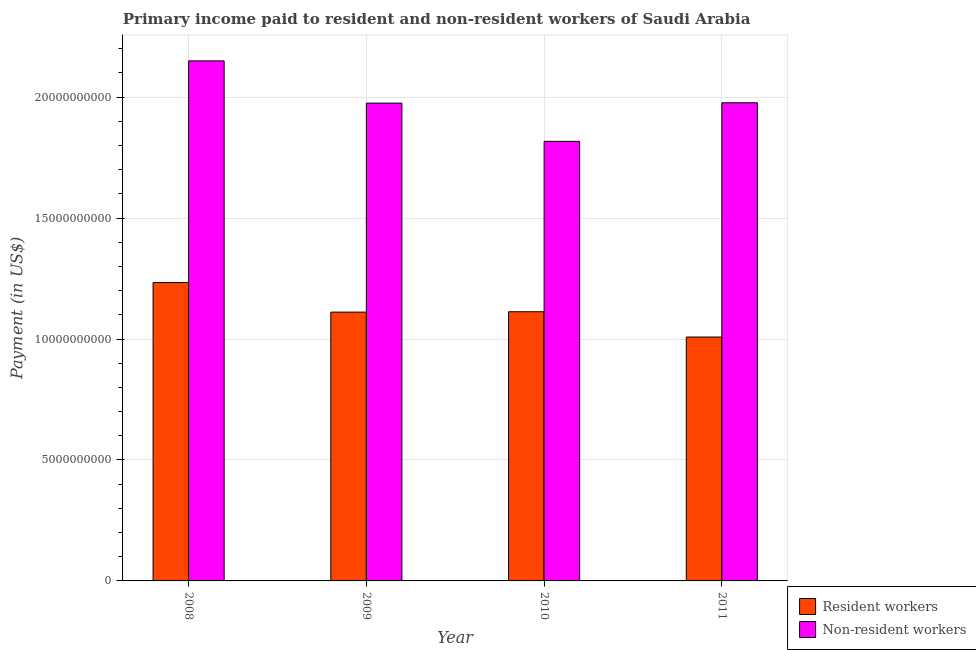How many groups of bars are there?
Your answer should be compact. 4. How many bars are there on the 4th tick from the left?
Your response must be concise. 2. What is the label of the 3rd group of bars from the left?
Offer a very short reply. 2010. In how many cases, is the number of bars for a given year not equal to the number of legend labels?
Give a very brief answer. 0. What is the payment made to non-resident workers in 2010?
Your answer should be very brief. 1.82e+1. Across all years, what is the maximum payment made to resident workers?
Your answer should be very brief. 1.23e+1. Across all years, what is the minimum payment made to resident workers?
Offer a terse response. 1.01e+1. In which year was the payment made to resident workers minimum?
Offer a very short reply. 2011. What is the total payment made to non-resident workers in the graph?
Ensure brevity in your answer.  7.92e+1. What is the difference between the payment made to resident workers in 2008 and that in 2011?
Provide a short and direct response. 2.25e+09. What is the difference between the payment made to resident workers in 2010 and the payment made to non-resident workers in 2009?
Give a very brief answer. 1.51e+07. What is the average payment made to non-resident workers per year?
Provide a short and direct response. 1.98e+1. In the year 2008, what is the difference between the payment made to resident workers and payment made to non-resident workers?
Provide a short and direct response. 0. In how many years, is the payment made to non-resident workers greater than 18000000000 US$?
Offer a very short reply. 4. What is the ratio of the payment made to resident workers in 2009 to that in 2011?
Your answer should be compact. 1.1. What is the difference between the highest and the second highest payment made to non-resident workers?
Ensure brevity in your answer.  1.73e+09. What is the difference between the highest and the lowest payment made to non-resident workers?
Your answer should be very brief. 3.33e+09. In how many years, is the payment made to resident workers greater than the average payment made to resident workers taken over all years?
Provide a succinct answer. 1. Is the sum of the payment made to non-resident workers in 2009 and 2010 greater than the maximum payment made to resident workers across all years?
Provide a succinct answer. Yes. What does the 2nd bar from the left in 2008 represents?
Ensure brevity in your answer.  Non-resident workers. What does the 1st bar from the right in 2008 represents?
Your answer should be compact. Non-resident workers. How many bars are there?
Your answer should be very brief. 8. How many years are there in the graph?
Your answer should be very brief. 4. What is the difference between two consecutive major ticks on the Y-axis?
Offer a very short reply. 5.00e+09. Does the graph contain any zero values?
Your answer should be very brief. No. Does the graph contain grids?
Keep it short and to the point. Yes. Where does the legend appear in the graph?
Provide a succinct answer. Bottom right. How many legend labels are there?
Your response must be concise. 2. How are the legend labels stacked?
Your answer should be compact. Vertical. What is the title of the graph?
Make the answer very short. Primary income paid to resident and non-resident workers of Saudi Arabia. Does "Imports" appear as one of the legend labels in the graph?
Your answer should be very brief. No. What is the label or title of the X-axis?
Offer a terse response. Year. What is the label or title of the Y-axis?
Provide a succinct answer. Payment (in US$). What is the Payment (in US$) in Resident workers in 2008?
Provide a short and direct response. 1.23e+1. What is the Payment (in US$) of Non-resident workers in 2008?
Your answer should be very brief. 2.15e+1. What is the Payment (in US$) in Resident workers in 2009?
Your answer should be compact. 1.11e+1. What is the Payment (in US$) in Non-resident workers in 2009?
Offer a terse response. 1.98e+1. What is the Payment (in US$) of Resident workers in 2010?
Provide a short and direct response. 1.11e+1. What is the Payment (in US$) of Non-resident workers in 2010?
Provide a succinct answer. 1.82e+1. What is the Payment (in US$) in Resident workers in 2011?
Ensure brevity in your answer.  1.01e+1. What is the Payment (in US$) of Non-resident workers in 2011?
Ensure brevity in your answer.  1.98e+1. Across all years, what is the maximum Payment (in US$) of Resident workers?
Your response must be concise. 1.23e+1. Across all years, what is the maximum Payment (in US$) of Non-resident workers?
Provide a succinct answer. 2.15e+1. Across all years, what is the minimum Payment (in US$) of Resident workers?
Offer a terse response. 1.01e+1. Across all years, what is the minimum Payment (in US$) in Non-resident workers?
Ensure brevity in your answer.  1.82e+1. What is the total Payment (in US$) in Resident workers in the graph?
Offer a terse response. 4.47e+1. What is the total Payment (in US$) of Non-resident workers in the graph?
Provide a succinct answer. 7.92e+1. What is the difference between the Payment (in US$) of Resident workers in 2008 and that in 2009?
Offer a terse response. 1.22e+09. What is the difference between the Payment (in US$) of Non-resident workers in 2008 and that in 2009?
Your answer should be compact. 1.75e+09. What is the difference between the Payment (in US$) of Resident workers in 2008 and that in 2010?
Make the answer very short. 1.21e+09. What is the difference between the Payment (in US$) of Non-resident workers in 2008 and that in 2010?
Your response must be concise. 3.33e+09. What is the difference between the Payment (in US$) of Resident workers in 2008 and that in 2011?
Offer a terse response. 2.25e+09. What is the difference between the Payment (in US$) of Non-resident workers in 2008 and that in 2011?
Your response must be concise. 1.73e+09. What is the difference between the Payment (in US$) in Resident workers in 2009 and that in 2010?
Offer a terse response. -1.51e+07. What is the difference between the Payment (in US$) of Non-resident workers in 2009 and that in 2010?
Offer a terse response. 1.58e+09. What is the difference between the Payment (in US$) in Resident workers in 2009 and that in 2011?
Your answer should be compact. 1.03e+09. What is the difference between the Payment (in US$) of Non-resident workers in 2009 and that in 2011?
Provide a short and direct response. -1.37e+07. What is the difference between the Payment (in US$) in Resident workers in 2010 and that in 2011?
Offer a very short reply. 1.05e+09. What is the difference between the Payment (in US$) of Non-resident workers in 2010 and that in 2011?
Your answer should be very brief. -1.59e+09. What is the difference between the Payment (in US$) in Resident workers in 2008 and the Payment (in US$) in Non-resident workers in 2009?
Your answer should be compact. -7.42e+09. What is the difference between the Payment (in US$) in Resident workers in 2008 and the Payment (in US$) in Non-resident workers in 2010?
Provide a short and direct response. -5.84e+09. What is the difference between the Payment (in US$) of Resident workers in 2008 and the Payment (in US$) of Non-resident workers in 2011?
Your response must be concise. -7.43e+09. What is the difference between the Payment (in US$) in Resident workers in 2009 and the Payment (in US$) in Non-resident workers in 2010?
Your answer should be very brief. -7.06e+09. What is the difference between the Payment (in US$) of Resident workers in 2009 and the Payment (in US$) of Non-resident workers in 2011?
Your answer should be compact. -8.65e+09. What is the difference between the Payment (in US$) in Resident workers in 2010 and the Payment (in US$) in Non-resident workers in 2011?
Provide a succinct answer. -8.64e+09. What is the average Payment (in US$) of Resident workers per year?
Your answer should be compact. 1.12e+1. What is the average Payment (in US$) in Non-resident workers per year?
Offer a terse response. 1.98e+1. In the year 2008, what is the difference between the Payment (in US$) of Resident workers and Payment (in US$) of Non-resident workers?
Make the answer very short. -9.16e+09. In the year 2009, what is the difference between the Payment (in US$) in Resident workers and Payment (in US$) in Non-resident workers?
Provide a short and direct response. -8.64e+09. In the year 2010, what is the difference between the Payment (in US$) of Resident workers and Payment (in US$) of Non-resident workers?
Your answer should be compact. -7.04e+09. In the year 2011, what is the difference between the Payment (in US$) in Resident workers and Payment (in US$) in Non-resident workers?
Make the answer very short. -9.68e+09. What is the ratio of the Payment (in US$) in Resident workers in 2008 to that in 2009?
Provide a short and direct response. 1.11. What is the ratio of the Payment (in US$) in Non-resident workers in 2008 to that in 2009?
Provide a short and direct response. 1.09. What is the ratio of the Payment (in US$) of Resident workers in 2008 to that in 2010?
Keep it short and to the point. 1.11. What is the ratio of the Payment (in US$) of Non-resident workers in 2008 to that in 2010?
Give a very brief answer. 1.18. What is the ratio of the Payment (in US$) of Resident workers in 2008 to that in 2011?
Make the answer very short. 1.22. What is the ratio of the Payment (in US$) of Non-resident workers in 2008 to that in 2011?
Make the answer very short. 1.09. What is the ratio of the Payment (in US$) of Non-resident workers in 2009 to that in 2010?
Your answer should be compact. 1.09. What is the ratio of the Payment (in US$) of Resident workers in 2009 to that in 2011?
Your answer should be compact. 1.1. What is the ratio of the Payment (in US$) in Non-resident workers in 2009 to that in 2011?
Offer a very short reply. 1. What is the ratio of the Payment (in US$) in Resident workers in 2010 to that in 2011?
Ensure brevity in your answer.  1.1. What is the ratio of the Payment (in US$) of Non-resident workers in 2010 to that in 2011?
Your answer should be compact. 0.92. What is the difference between the highest and the second highest Payment (in US$) in Resident workers?
Provide a short and direct response. 1.21e+09. What is the difference between the highest and the second highest Payment (in US$) in Non-resident workers?
Offer a very short reply. 1.73e+09. What is the difference between the highest and the lowest Payment (in US$) of Resident workers?
Offer a terse response. 2.25e+09. What is the difference between the highest and the lowest Payment (in US$) in Non-resident workers?
Your answer should be compact. 3.33e+09. 